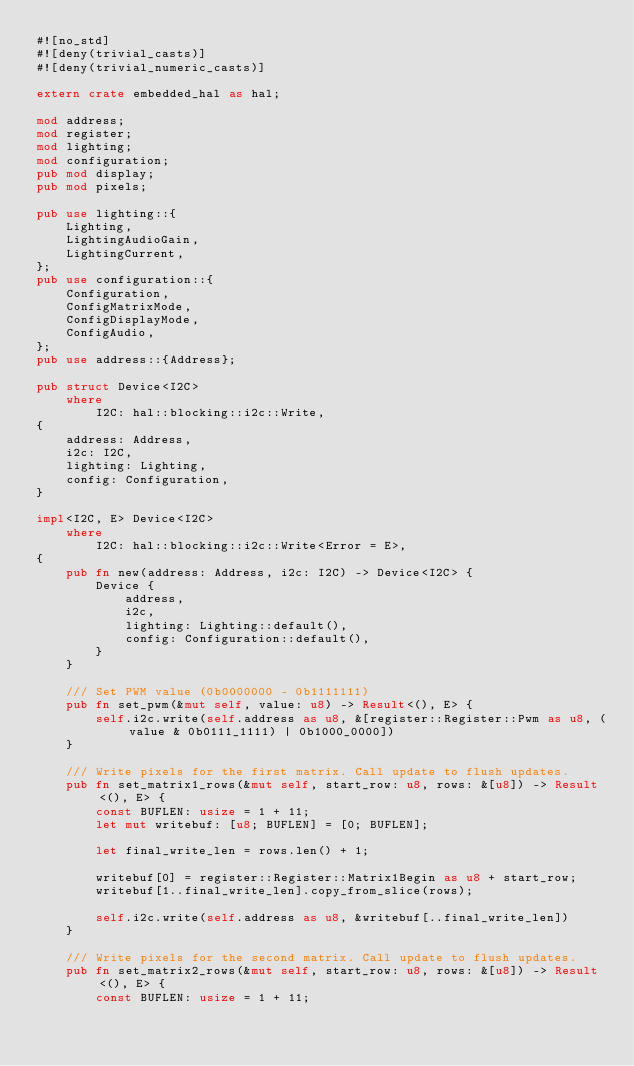Convert code to text. <code><loc_0><loc_0><loc_500><loc_500><_Rust_>#![no_std]
#![deny(trivial_casts)]
#![deny(trivial_numeric_casts)]

extern crate embedded_hal as hal;

mod address;
mod register;
mod lighting;
mod configuration;
pub mod display;
pub mod pixels;

pub use lighting::{
    Lighting,
    LightingAudioGain,
    LightingCurrent,
};
pub use configuration::{
    Configuration,
    ConfigMatrixMode,
    ConfigDisplayMode,
    ConfigAudio,
};
pub use address::{Address};

pub struct Device<I2C>
    where
        I2C: hal::blocking::i2c::Write,
{
    address: Address,
    i2c: I2C,
    lighting: Lighting,
    config: Configuration,
}

impl<I2C, E> Device<I2C>
    where
        I2C: hal::blocking::i2c::Write<Error = E>,
{
    pub fn new(address: Address, i2c: I2C) -> Device<I2C> {
        Device {
            address,
            i2c,
            lighting: Lighting::default(),
            config: Configuration::default(),
        }
    }

    /// Set PWM value (0b0000000 - 0b1111111)
    pub fn set_pwm(&mut self, value: u8) -> Result<(), E> {
        self.i2c.write(self.address as u8, &[register::Register::Pwm as u8, (value & 0b0111_1111) | 0b1000_0000])
    }

    /// Write pixels for the first matrix. Call update to flush updates.
    pub fn set_matrix1_rows(&mut self, start_row: u8, rows: &[u8]) -> Result<(), E> {
        const BUFLEN: usize = 1 + 11;
        let mut writebuf: [u8; BUFLEN] = [0; BUFLEN];

        let final_write_len = rows.len() + 1;

        writebuf[0] = register::Register::Matrix1Begin as u8 + start_row;
        writebuf[1..final_write_len].copy_from_slice(rows);

        self.i2c.write(self.address as u8, &writebuf[..final_write_len])
    }

    /// Write pixels for the second matrix. Call update to flush updates.
    pub fn set_matrix2_rows(&mut self, start_row: u8, rows: &[u8]) -> Result<(), E> {
        const BUFLEN: usize = 1 + 11;</code> 